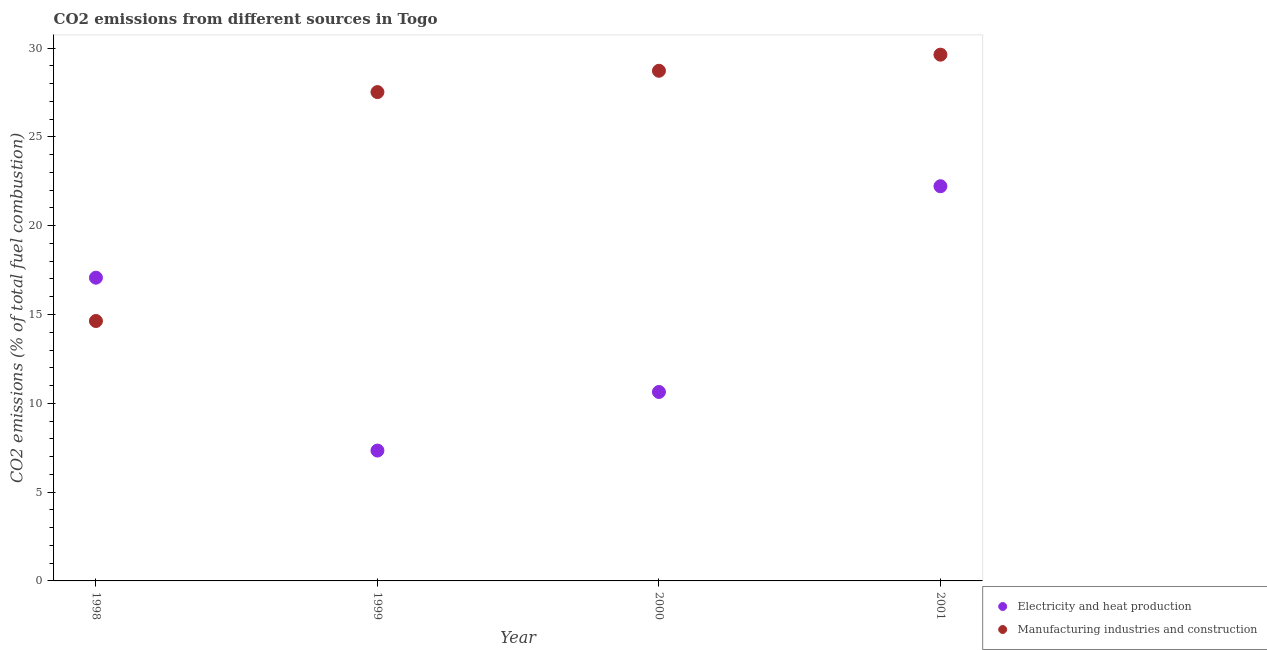How many different coloured dotlines are there?
Provide a succinct answer. 2. What is the co2 emissions due to electricity and heat production in 1999?
Ensure brevity in your answer.  7.34. Across all years, what is the maximum co2 emissions due to electricity and heat production?
Your answer should be very brief. 22.22. Across all years, what is the minimum co2 emissions due to electricity and heat production?
Ensure brevity in your answer.  7.34. In which year was the co2 emissions due to manufacturing industries maximum?
Offer a terse response. 2001. What is the total co2 emissions due to electricity and heat production in the graph?
Your answer should be very brief. 57.27. What is the difference between the co2 emissions due to electricity and heat production in 1998 and that in 2001?
Offer a terse response. -5.15. What is the difference between the co2 emissions due to electricity and heat production in 2001 and the co2 emissions due to manufacturing industries in 1999?
Offer a very short reply. -5.3. What is the average co2 emissions due to electricity and heat production per year?
Offer a very short reply. 14.32. In the year 1998, what is the difference between the co2 emissions due to manufacturing industries and co2 emissions due to electricity and heat production?
Provide a succinct answer. -2.44. In how many years, is the co2 emissions due to electricity and heat production greater than 20 %?
Ensure brevity in your answer.  1. What is the ratio of the co2 emissions due to manufacturing industries in 1998 to that in 2001?
Give a very brief answer. 0.49. What is the difference between the highest and the second highest co2 emissions due to electricity and heat production?
Offer a very short reply. 5.15. What is the difference between the highest and the lowest co2 emissions due to manufacturing industries?
Keep it short and to the point. 15. Is the sum of the co2 emissions due to manufacturing industries in 1998 and 2001 greater than the maximum co2 emissions due to electricity and heat production across all years?
Provide a short and direct response. Yes. Does the co2 emissions due to electricity and heat production monotonically increase over the years?
Ensure brevity in your answer.  No. Is the co2 emissions due to electricity and heat production strictly greater than the co2 emissions due to manufacturing industries over the years?
Make the answer very short. No. Is the co2 emissions due to manufacturing industries strictly less than the co2 emissions due to electricity and heat production over the years?
Your answer should be compact. No. How many years are there in the graph?
Give a very brief answer. 4. What is the difference between two consecutive major ticks on the Y-axis?
Your answer should be very brief. 5. Are the values on the major ticks of Y-axis written in scientific E-notation?
Your answer should be very brief. No. What is the title of the graph?
Ensure brevity in your answer.  CO2 emissions from different sources in Togo. Does "Mobile cellular" appear as one of the legend labels in the graph?
Offer a terse response. No. What is the label or title of the Y-axis?
Provide a succinct answer. CO2 emissions (% of total fuel combustion). What is the CO2 emissions (% of total fuel combustion) in Electricity and heat production in 1998?
Your answer should be very brief. 17.07. What is the CO2 emissions (% of total fuel combustion) in Manufacturing industries and construction in 1998?
Your answer should be very brief. 14.63. What is the CO2 emissions (% of total fuel combustion) in Electricity and heat production in 1999?
Offer a terse response. 7.34. What is the CO2 emissions (% of total fuel combustion) of Manufacturing industries and construction in 1999?
Provide a succinct answer. 27.52. What is the CO2 emissions (% of total fuel combustion) of Electricity and heat production in 2000?
Your response must be concise. 10.64. What is the CO2 emissions (% of total fuel combustion) in Manufacturing industries and construction in 2000?
Provide a short and direct response. 28.72. What is the CO2 emissions (% of total fuel combustion) of Electricity and heat production in 2001?
Provide a succinct answer. 22.22. What is the CO2 emissions (% of total fuel combustion) of Manufacturing industries and construction in 2001?
Provide a succinct answer. 29.63. Across all years, what is the maximum CO2 emissions (% of total fuel combustion) of Electricity and heat production?
Your answer should be compact. 22.22. Across all years, what is the maximum CO2 emissions (% of total fuel combustion) of Manufacturing industries and construction?
Ensure brevity in your answer.  29.63. Across all years, what is the minimum CO2 emissions (% of total fuel combustion) in Electricity and heat production?
Provide a succinct answer. 7.34. Across all years, what is the minimum CO2 emissions (% of total fuel combustion) of Manufacturing industries and construction?
Make the answer very short. 14.63. What is the total CO2 emissions (% of total fuel combustion) of Electricity and heat production in the graph?
Make the answer very short. 57.27. What is the total CO2 emissions (% of total fuel combustion) in Manufacturing industries and construction in the graph?
Ensure brevity in your answer.  100.51. What is the difference between the CO2 emissions (% of total fuel combustion) of Electricity and heat production in 1998 and that in 1999?
Your answer should be very brief. 9.73. What is the difference between the CO2 emissions (% of total fuel combustion) in Manufacturing industries and construction in 1998 and that in 1999?
Your answer should be very brief. -12.89. What is the difference between the CO2 emissions (% of total fuel combustion) of Electricity and heat production in 1998 and that in 2000?
Provide a short and direct response. 6.43. What is the difference between the CO2 emissions (% of total fuel combustion) in Manufacturing industries and construction in 1998 and that in 2000?
Provide a short and direct response. -14.09. What is the difference between the CO2 emissions (% of total fuel combustion) of Electricity and heat production in 1998 and that in 2001?
Keep it short and to the point. -5.15. What is the difference between the CO2 emissions (% of total fuel combustion) of Manufacturing industries and construction in 1998 and that in 2001?
Your answer should be compact. -15. What is the difference between the CO2 emissions (% of total fuel combustion) of Electricity and heat production in 1999 and that in 2000?
Offer a terse response. -3.3. What is the difference between the CO2 emissions (% of total fuel combustion) in Manufacturing industries and construction in 1999 and that in 2000?
Your response must be concise. -1.2. What is the difference between the CO2 emissions (% of total fuel combustion) of Electricity and heat production in 1999 and that in 2001?
Offer a terse response. -14.88. What is the difference between the CO2 emissions (% of total fuel combustion) of Manufacturing industries and construction in 1999 and that in 2001?
Your response must be concise. -2.11. What is the difference between the CO2 emissions (% of total fuel combustion) in Electricity and heat production in 2000 and that in 2001?
Your answer should be compact. -11.58. What is the difference between the CO2 emissions (% of total fuel combustion) of Manufacturing industries and construction in 2000 and that in 2001?
Your response must be concise. -0.91. What is the difference between the CO2 emissions (% of total fuel combustion) in Electricity and heat production in 1998 and the CO2 emissions (% of total fuel combustion) in Manufacturing industries and construction in 1999?
Give a very brief answer. -10.45. What is the difference between the CO2 emissions (% of total fuel combustion) in Electricity and heat production in 1998 and the CO2 emissions (% of total fuel combustion) in Manufacturing industries and construction in 2000?
Give a very brief answer. -11.65. What is the difference between the CO2 emissions (% of total fuel combustion) of Electricity and heat production in 1998 and the CO2 emissions (% of total fuel combustion) of Manufacturing industries and construction in 2001?
Your answer should be very brief. -12.56. What is the difference between the CO2 emissions (% of total fuel combustion) in Electricity and heat production in 1999 and the CO2 emissions (% of total fuel combustion) in Manufacturing industries and construction in 2000?
Provide a short and direct response. -21.38. What is the difference between the CO2 emissions (% of total fuel combustion) in Electricity and heat production in 1999 and the CO2 emissions (% of total fuel combustion) in Manufacturing industries and construction in 2001?
Keep it short and to the point. -22.29. What is the difference between the CO2 emissions (% of total fuel combustion) in Electricity and heat production in 2000 and the CO2 emissions (% of total fuel combustion) in Manufacturing industries and construction in 2001?
Ensure brevity in your answer.  -18.99. What is the average CO2 emissions (% of total fuel combustion) of Electricity and heat production per year?
Ensure brevity in your answer.  14.32. What is the average CO2 emissions (% of total fuel combustion) of Manufacturing industries and construction per year?
Offer a terse response. 25.13. In the year 1998, what is the difference between the CO2 emissions (% of total fuel combustion) in Electricity and heat production and CO2 emissions (% of total fuel combustion) in Manufacturing industries and construction?
Your answer should be compact. 2.44. In the year 1999, what is the difference between the CO2 emissions (% of total fuel combustion) in Electricity and heat production and CO2 emissions (% of total fuel combustion) in Manufacturing industries and construction?
Your answer should be compact. -20.18. In the year 2000, what is the difference between the CO2 emissions (% of total fuel combustion) of Electricity and heat production and CO2 emissions (% of total fuel combustion) of Manufacturing industries and construction?
Your response must be concise. -18.09. In the year 2001, what is the difference between the CO2 emissions (% of total fuel combustion) of Electricity and heat production and CO2 emissions (% of total fuel combustion) of Manufacturing industries and construction?
Your response must be concise. -7.41. What is the ratio of the CO2 emissions (% of total fuel combustion) of Electricity and heat production in 1998 to that in 1999?
Your response must be concise. 2.33. What is the ratio of the CO2 emissions (% of total fuel combustion) in Manufacturing industries and construction in 1998 to that in 1999?
Your answer should be very brief. 0.53. What is the ratio of the CO2 emissions (% of total fuel combustion) of Electricity and heat production in 1998 to that in 2000?
Keep it short and to the point. 1.6. What is the ratio of the CO2 emissions (% of total fuel combustion) in Manufacturing industries and construction in 1998 to that in 2000?
Provide a succinct answer. 0.51. What is the ratio of the CO2 emissions (% of total fuel combustion) of Electricity and heat production in 1998 to that in 2001?
Provide a short and direct response. 0.77. What is the ratio of the CO2 emissions (% of total fuel combustion) of Manufacturing industries and construction in 1998 to that in 2001?
Offer a very short reply. 0.49. What is the ratio of the CO2 emissions (% of total fuel combustion) of Electricity and heat production in 1999 to that in 2000?
Offer a very short reply. 0.69. What is the ratio of the CO2 emissions (% of total fuel combustion) of Manufacturing industries and construction in 1999 to that in 2000?
Provide a succinct answer. 0.96. What is the ratio of the CO2 emissions (% of total fuel combustion) of Electricity and heat production in 1999 to that in 2001?
Make the answer very short. 0.33. What is the ratio of the CO2 emissions (% of total fuel combustion) in Manufacturing industries and construction in 1999 to that in 2001?
Your answer should be very brief. 0.93. What is the ratio of the CO2 emissions (% of total fuel combustion) in Electricity and heat production in 2000 to that in 2001?
Your answer should be compact. 0.48. What is the ratio of the CO2 emissions (% of total fuel combustion) in Manufacturing industries and construction in 2000 to that in 2001?
Your answer should be very brief. 0.97. What is the difference between the highest and the second highest CO2 emissions (% of total fuel combustion) in Electricity and heat production?
Your answer should be compact. 5.15. What is the difference between the highest and the second highest CO2 emissions (% of total fuel combustion) of Manufacturing industries and construction?
Give a very brief answer. 0.91. What is the difference between the highest and the lowest CO2 emissions (% of total fuel combustion) in Electricity and heat production?
Offer a terse response. 14.88. What is the difference between the highest and the lowest CO2 emissions (% of total fuel combustion) in Manufacturing industries and construction?
Keep it short and to the point. 15. 